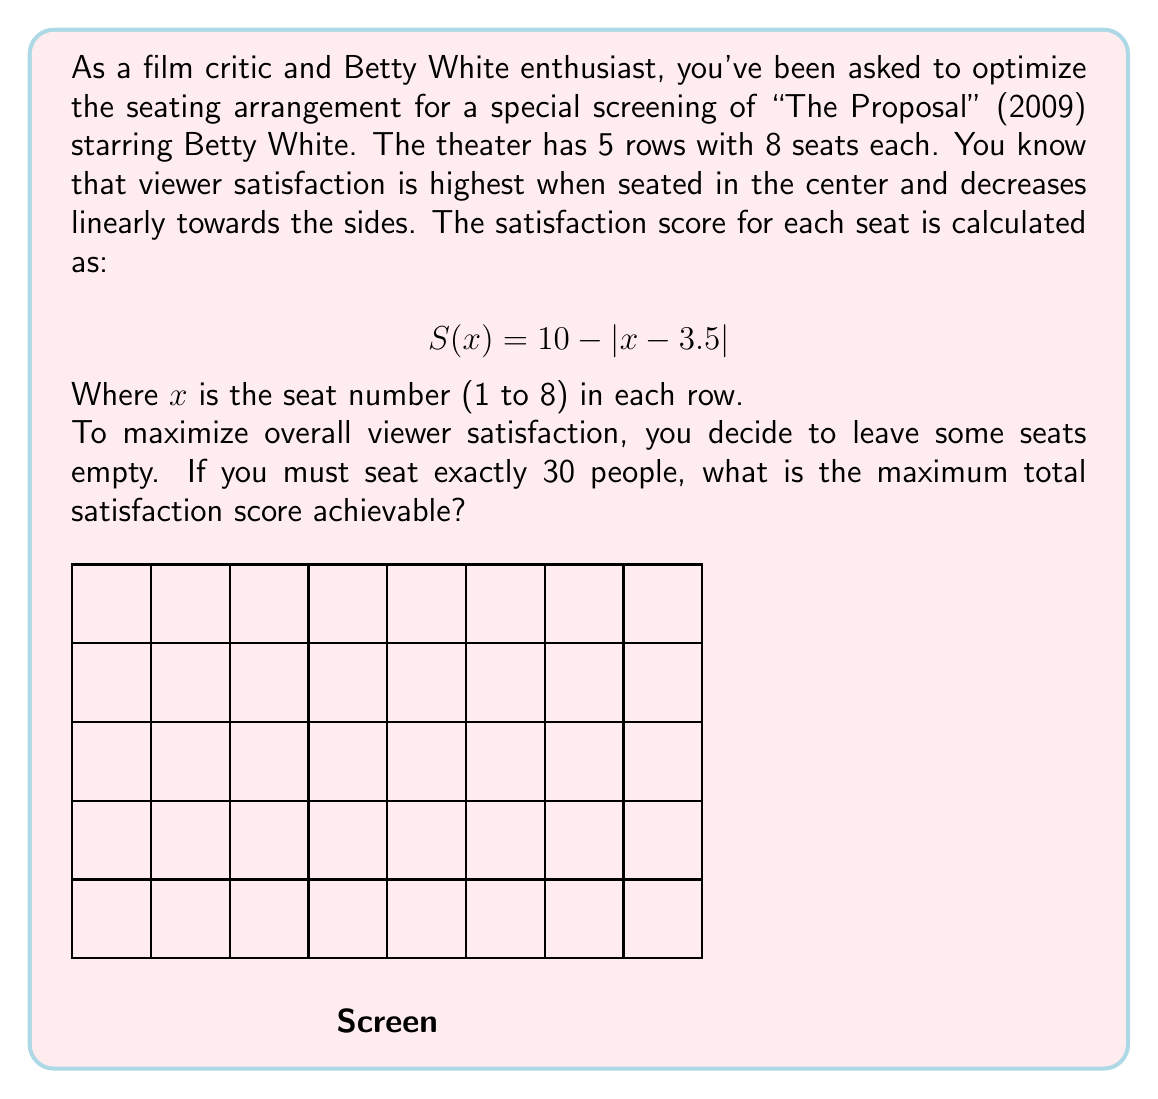Help me with this question. Let's approach this step-by-step:

1) First, we need to calculate the satisfaction score for each seat:
   $S(1) = 10 - |1 - 3.5| = 7.5$
   $S(2) = 10 - |2 - 3.5| = 8.5$
   $S(3) = 10 - |3 - 3.5| = 9.5$
   $S(4) = 10 - |4 - 3.5| = 9.5$
   $S(5) = 10 - |5 - 3.5| = 8.5$
   $S(6) = 10 - |6 - 3.5| = 7.5$
   $S(7) = 10 - |7 - 3.5| = 6.5$
   $S(8) = 10 - |8 - 3.5| = 5.5$

2) We see that the seats are symmetrical, with the highest satisfaction in the center (seats 3 and 4) and decreasing towards the sides.

3) To maximize satisfaction, we should fill the seats from the center outwards. With 5 rows, we need to seat 6 people per row on average.

4) The optimal arrangement per row would be to fill seats 2, 3, 4, 5, 6, and 7, leaving 1 and 8 empty.

5) The total satisfaction score for one row with this arrangement is:
   $8.5 + 9.5 + 9.5 + 8.5 + 7.5 + 6.5 = 50$

6) With 5 identical rows, the total satisfaction score for the theater is:
   $50 * 5 = 250$

Therefore, the maximum total satisfaction score achievable is 250.
Answer: 250 